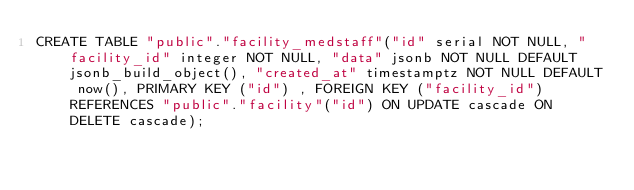Convert code to text. <code><loc_0><loc_0><loc_500><loc_500><_SQL_>CREATE TABLE "public"."facility_medstaff"("id" serial NOT NULL, "facility_id" integer NOT NULL, "data" jsonb NOT NULL DEFAULT jsonb_build_object(), "created_at" timestamptz NOT NULL DEFAULT now(), PRIMARY KEY ("id") , FOREIGN KEY ("facility_id") REFERENCES "public"."facility"("id") ON UPDATE cascade ON DELETE cascade);
</code> 